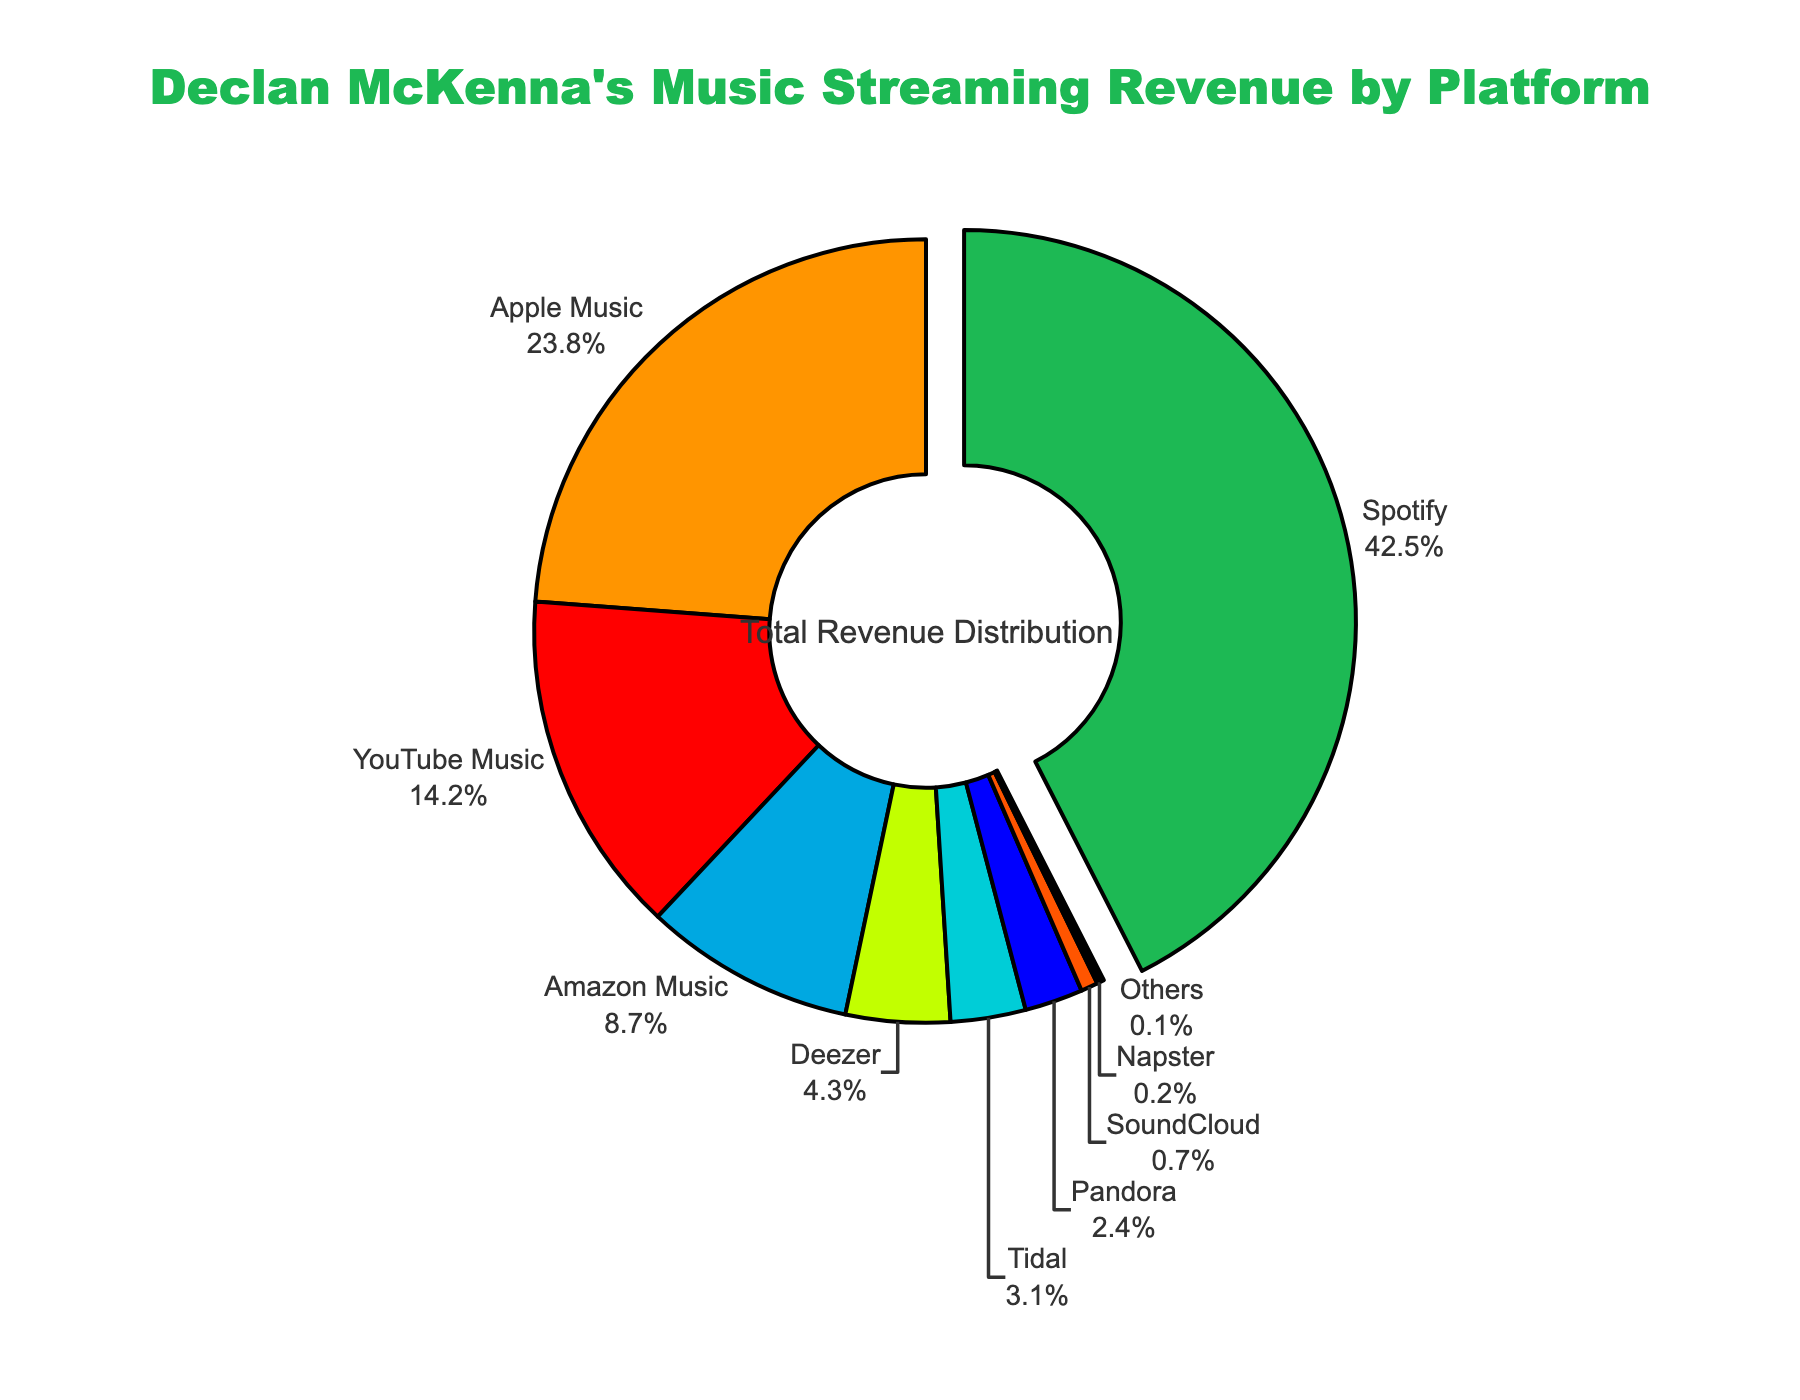What percentage of Declan McKenna's music streaming revenue comes from Apple Music and Amazon Music combined? To find the combined percentage, add the percentages for Apple Music and Amazon Music. So, it's 23.8% (Apple Music) + 8.7% (Amazon Music) = 32.5%.
Answer: 32.5% Which platform contributes the highest percentage to Declan McKenna's music streaming revenue? The platform with the highest percentage in the pie chart is Spotify with 42.5%.
Answer: Spotify What is the difference in the percentage of revenue between Spotify and YouTube Music? Subtract the percentage of YouTube Music from the percentage of Spotify: 42.5% (Spotify) - 14.2% (YouTube Music) = 28.3%.
Answer: 28.3% Which platform has the lowest contribution to Declan McKenna's music streaming revenue? The platform with the lowest percentage in the pie chart is "Others" with 0.1%.
Answer: Others What is the total revenue percentage for YouTube Music, Deezer, and Tidal combined? Add the percentages of YouTube Music, Deezer, and Tidal: 14.2% (YouTube Music) + 4.3% (Deezer) + 3.1% (Tidal) = 21.6%.
Answer: 21.6% How much larger in percentage is the revenue from Spotify compared to Apple Music? Subtract the percentage of Apple Music from the percentage of Spotify: 42.5% (Spotify) - 23.8% (Apple Music) = 18.7%.
Answer: 18.7% Which platform’s segment is colored green in the pie chart? The segment colored green represents Spotify as shown by the color and the associated percentage (42.5%).
Answer: Spotify What is the combined percentage of revenue generated by Deezer, Tidal, and Pandora? Add the percentages of Deezer, Tidal, and Pandora: 4.3% (Deezer) + 3.1% (Tidal) + 2.4% (Pandora) = 9.8%.
Answer: 9.8% How much larger in percentage is the contribution from Amazon Music compared to Pandora? Subtract the percentage of Pandora from the percentage of Amazon Music: 8.7% (Amazon Music) - 2.4% (Pandora) = 6.3%.
Answer: 6.3% What percentage of revenue comes from platforms other than Spotify, Apple Music, and YouTube Music? Add the percentages of all platforms except Spotify, Apple Music, and YouTube Music, then subtract from 100%: 100% - (42.5% + 23.8% + 14.2%) = 19.5%.
Answer: 19.5% 